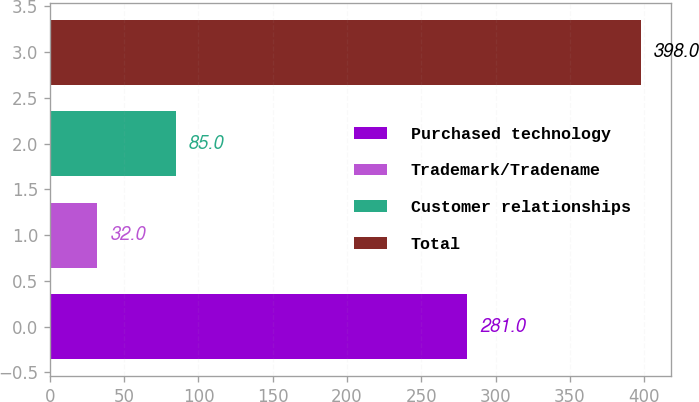Convert chart. <chart><loc_0><loc_0><loc_500><loc_500><bar_chart><fcel>Purchased technology<fcel>Trademark/Tradename<fcel>Customer relationships<fcel>Total<nl><fcel>281<fcel>32<fcel>85<fcel>398<nl></chart> 